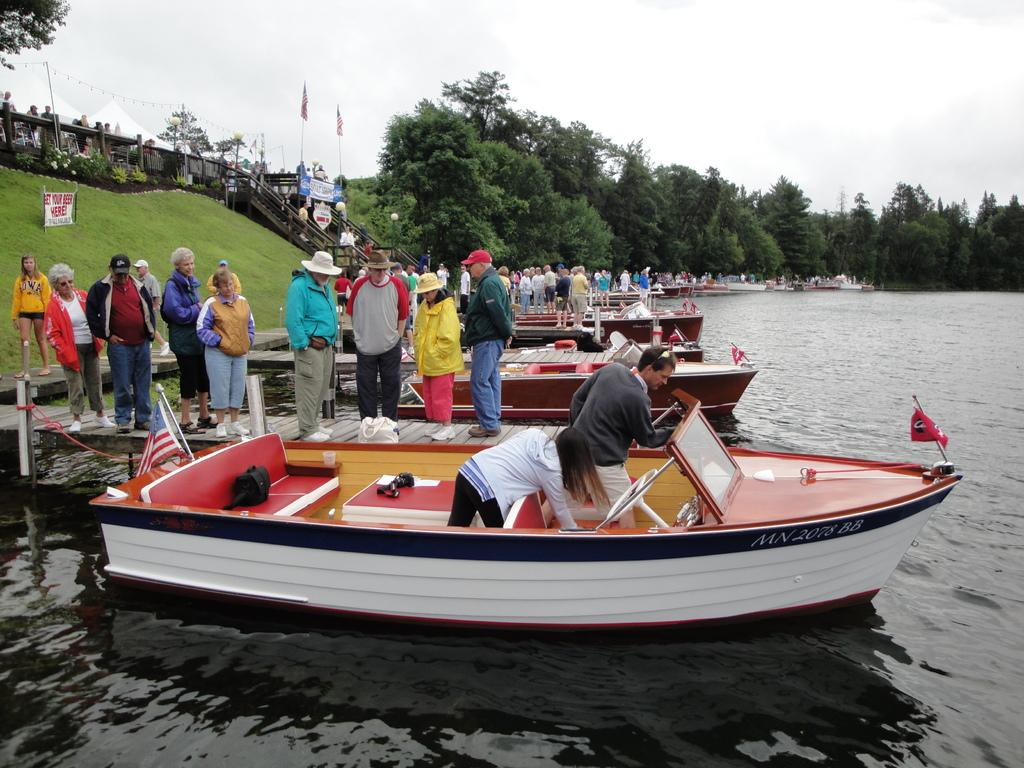<image>
Summarize the visual content of the image. A red and white banner on the grass reads "get your beer here" 